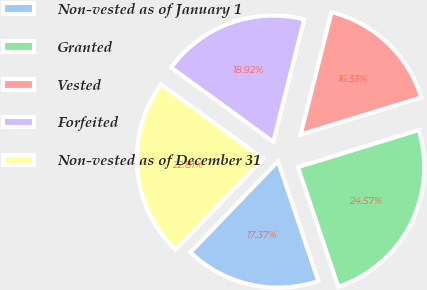Convert chart. <chart><loc_0><loc_0><loc_500><loc_500><pie_chart><fcel>Non-vested as of January 1<fcel>Granted<fcel>Vested<fcel>Forfeited<fcel>Non-vested as of December 31<nl><fcel>17.37%<fcel>24.57%<fcel>16.33%<fcel>18.92%<fcel>22.81%<nl></chart> 